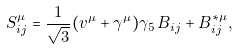<formula> <loc_0><loc_0><loc_500><loc_500>S ^ { \mu } _ { i j } = \frac { 1 } { \sqrt { 3 } } ( v ^ { \mu } + \gamma ^ { \mu } ) \gamma _ { 5 } \, B _ { i j } + B ^ { * \mu } _ { i j } ,</formula> 